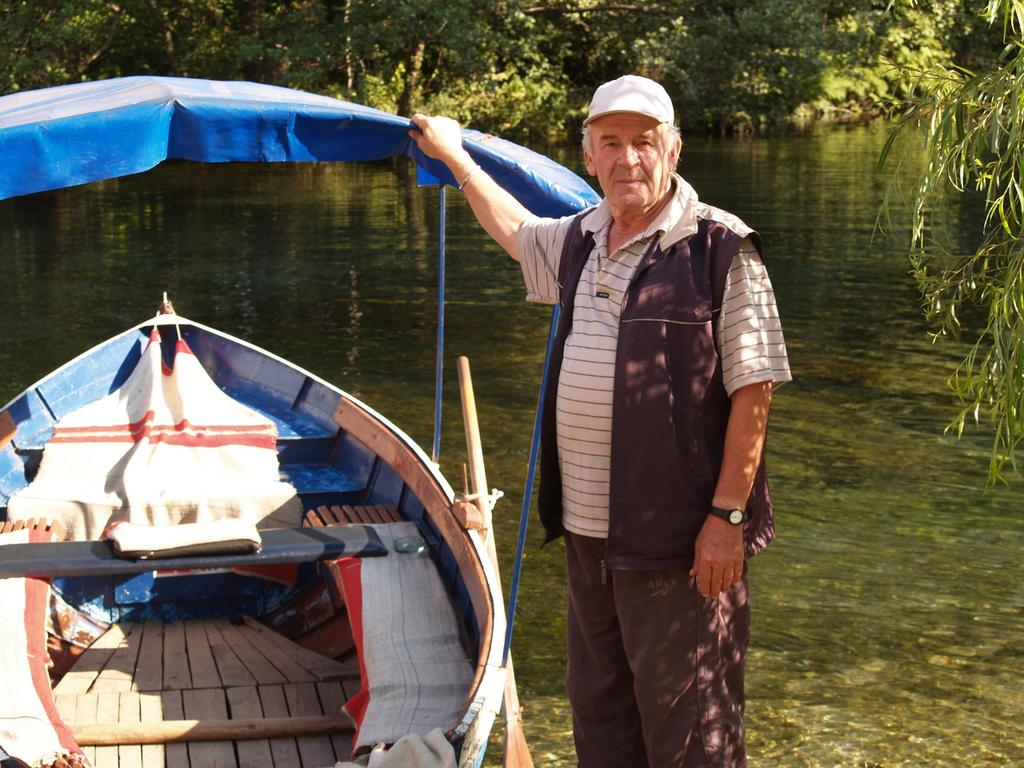What is located on the left side of the image? There is a boat in the water on the left side of the image. Who is present in the boat? A man is standing in the boat. What is the man doing in the boat? The man is holding the roof top of the boat. What can be seen in the background of the image? There are trees and water visible in the background of the image. What is the texture of the man's finger in the image? There is no information about the texture of the man's finger in the image, as it is not mentioned in the provided facts. 